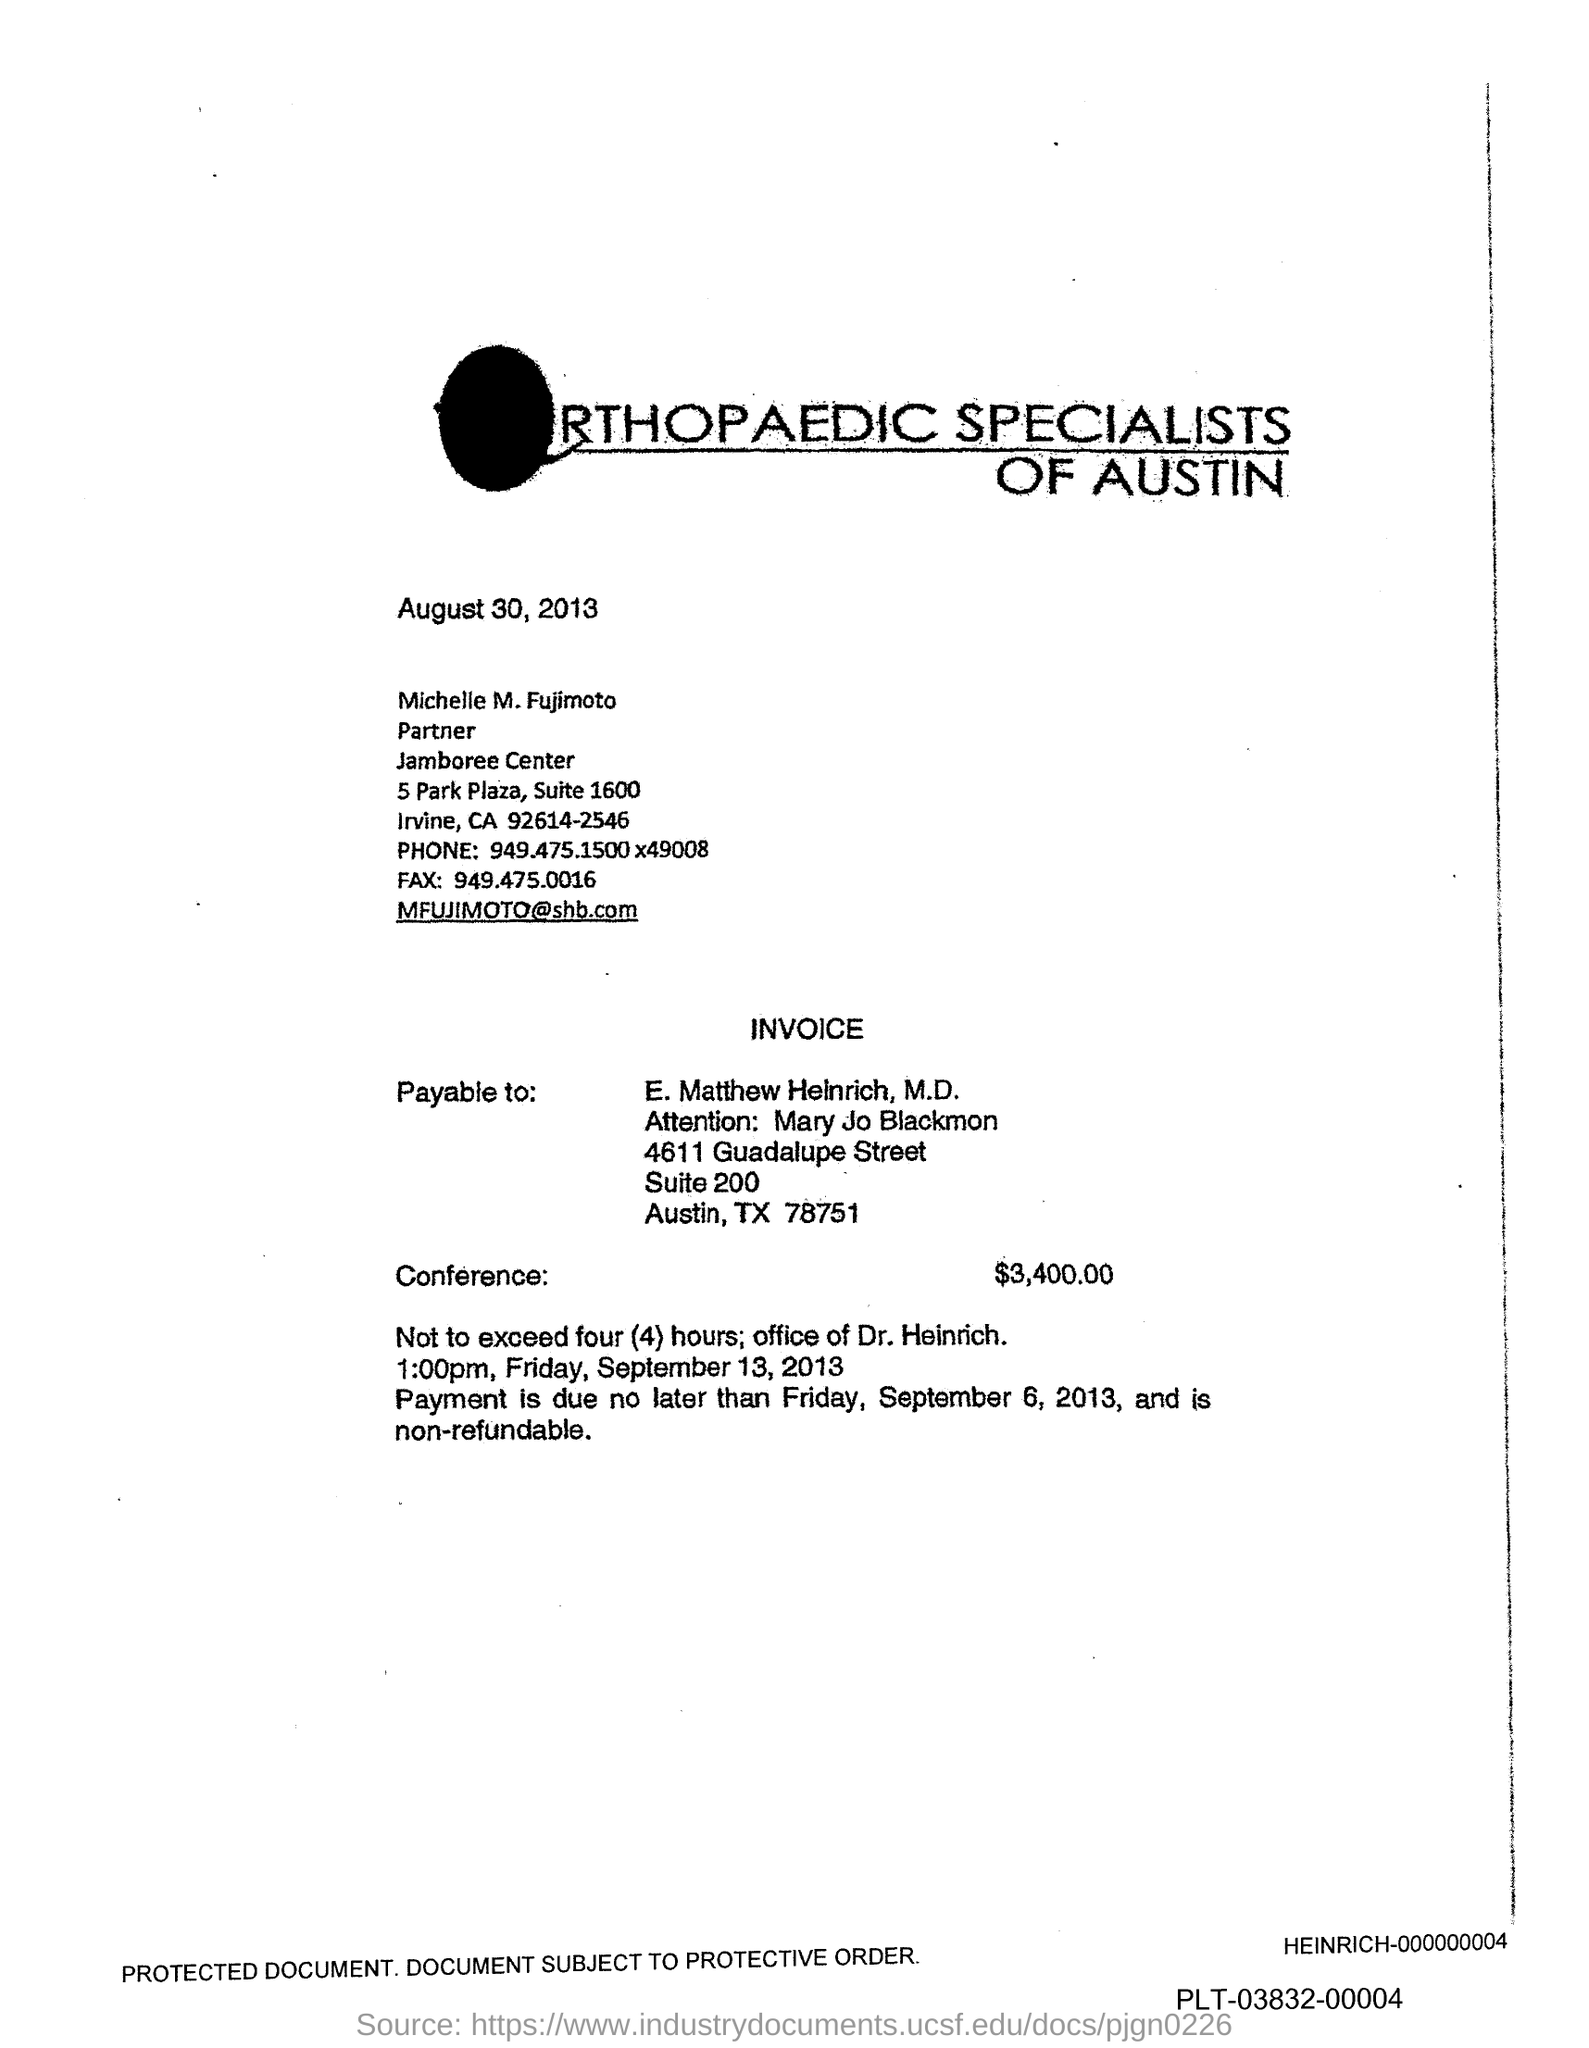What is the date mentioned  on the top of the page
Make the answer very short. August 30, 2013. To whom it is payable to ?
Your answer should be compact. E. Matthew Heinrich, M.D. How much is the conference amount
Your answer should be compact. 3,400.00. What is the phone number of fujimoto?
Keep it short and to the point. 949.475.1500x49008. What is the fax number mentioned ?
Ensure brevity in your answer.  949.475.0016. What is the mail id mentioned ?
Offer a very short reply. MFUJIMOTO@shb.com. Payment is due no later than which date ?
Keep it short and to the point. Friday, September 6, 2013. 